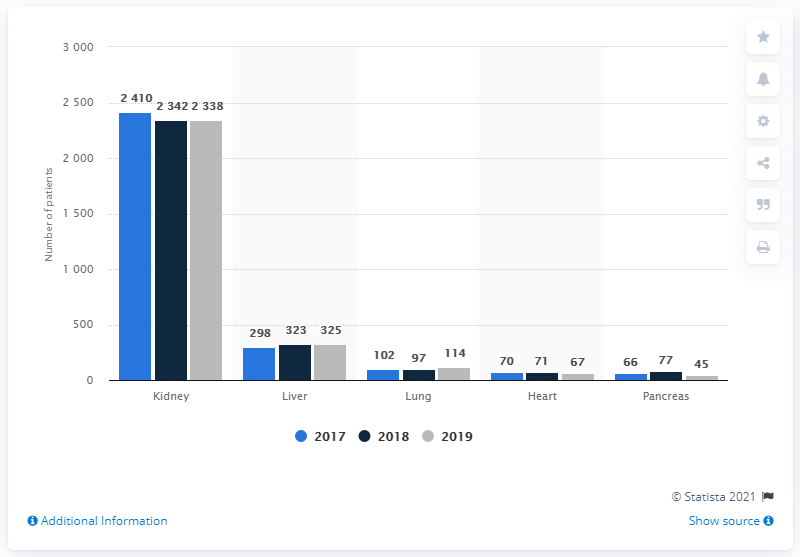Draw attention to some important aspects in this diagram. I declare that the organ with the highest filtration rate in all years is the kidney. In 2018, the second highest number of active organ transplants were performed. 